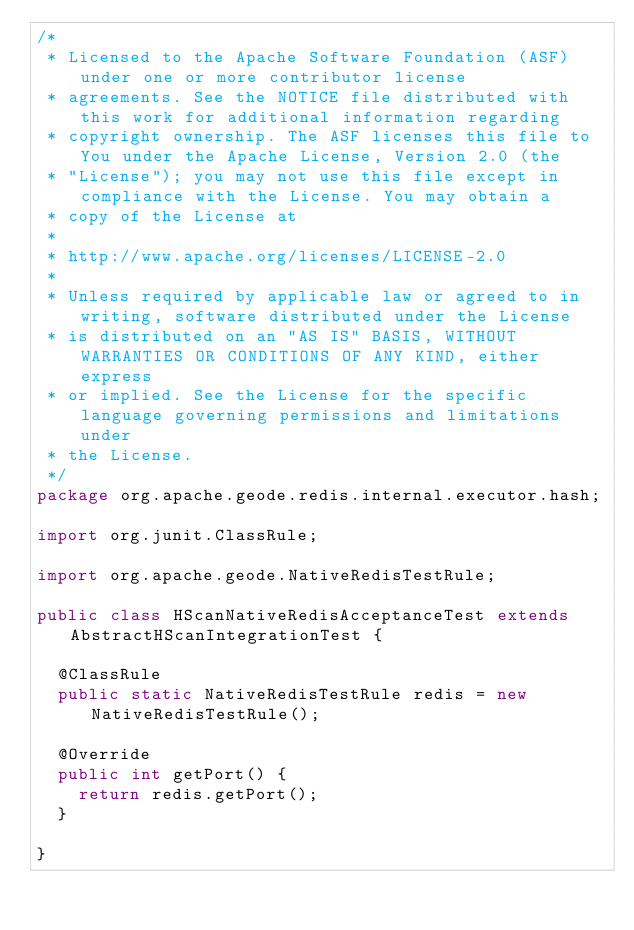<code> <loc_0><loc_0><loc_500><loc_500><_Java_>/*
 * Licensed to the Apache Software Foundation (ASF) under one or more contributor license
 * agreements. See the NOTICE file distributed with this work for additional information regarding
 * copyright ownership. The ASF licenses this file to You under the Apache License, Version 2.0 (the
 * "License"); you may not use this file except in compliance with the License. You may obtain a
 * copy of the License at
 *
 * http://www.apache.org/licenses/LICENSE-2.0
 *
 * Unless required by applicable law or agreed to in writing, software distributed under the License
 * is distributed on an "AS IS" BASIS, WITHOUT WARRANTIES OR CONDITIONS OF ANY KIND, either express
 * or implied. See the License for the specific language governing permissions and limitations under
 * the License.
 */
package org.apache.geode.redis.internal.executor.hash;

import org.junit.ClassRule;

import org.apache.geode.NativeRedisTestRule;

public class HScanNativeRedisAcceptanceTest extends AbstractHScanIntegrationTest {

  @ClassRule
  public static NativeRedisTestRule redis = new NativeRedisTestRule();

  @Override
  public int getPort() {
    return redis.getPort();
  }

}
</code> 